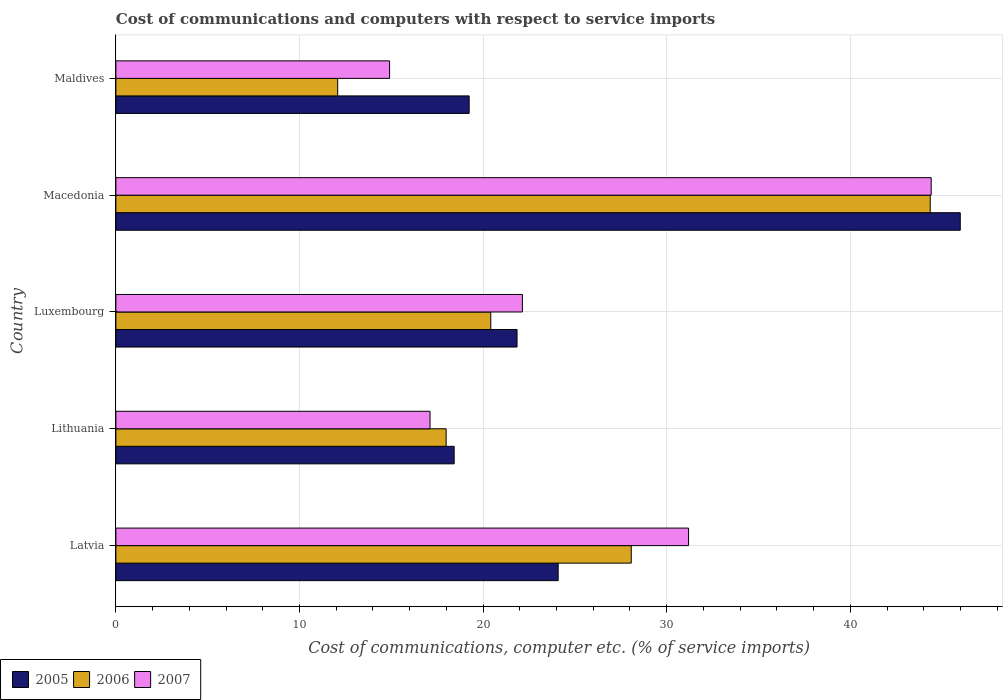How many bars are there on the 1st tick from the top?
Give a very brief answer. 3. How many bars are there on the 4th tick from the bottom?
Make the answer very short. 3. What is the label of the 5th group of bars from the top?
Keep it short and to the point. Latvia. In how many cases, is the number of bars for a given country not equal to the number of legend labels?
Give a very brief answer. 0. What is the cost of communications and computers in 2007 in Maldives?
Keep it short and to the point. 14.91. Across all countries, what is the maximum cost of communications and computers in 2005?
Keep it short and to the point. 45.99. Across all countries, what is the minimum cost of communications and computers in 2007?
Your answer should be very brief. 14.91. In which country was the cost of communications and computers in 2006 maximum?
Keep it short and to the point. Macedonia. In which country was the cost of communications and computers in 2007 minimum?
Ensure brevity in your answer.  Maldives. What is the total cost of communications and computers in 2007 in the graph?
Your answer should be compact. 129.76. What is the difference between the cost of communications and computers in 2006 in Luxembourg and that in Maldives?
Ensure brevity in your answer.  8.34. What is the difference between the cost of communications and computers in 2005 in Maldives and the cost of communications and computers in 2007 in Latvia?
Give a very brief answer. -11.95. What is the average cost of communications and computers in 2007 per country?
Your response must be concise. 25.95. What is the difference between the cost of communications and computers in 2007 and cost of communications and computers in 2005 in Maldives?
Offer a terse response. -4.33. What is the ratio of the cost of communications and computers in 2005 in Luxembourg to that in Macedonia?
Provide a short and direct response. 0.48. What is the difference between the highest and the second highest cost of communications and computers in 2006?
Provide a short and direct response. 16.28. What is the difference between the highest and the lowest cost of communications and computers in 2007?
Your answer should be compact. 29.5. In how many countries, is the cost of communications and computers in 2006 greater than the average cost of communications and computers in 2006 taken over all countries?
Provide a short and direct response. 2. What does the 1st bar from the top in Latvia represents?
Give a very brief answer. 2007. Is it the case that in every country, the sum of the cost of communications and computers in 2007 and cost of communications and computers in 2005 is greater than the cost of communications and computers in 2006?
Your response must be concise. Yes. How many bars are there?
Provide a short and direct response. 15. Are all the bars in the graph horizontal?
Your response must be concise. Yes. Are the values on the major ticks of X-axis written in scientific E-notation?
Your answer should be very brief. No. Does the graph contain any zero values?
Your answer should be compact. No. Does the graph contain grids?
Your answer should be very brief. Yes. What is the title of the graph?
Offer a terse response. Cost of communications and computers with respect to service imports. What is the label or title of the X-axis?
Ensure brevity in your answer.  Cost of communications, computer etc. (% of service imports). What is the Cost of communications, computer etc. (% of service imports) in 2005 in Latvia?
Your response must be concise. 24.09. What is the Cost of communications, computer etc. (% of service imports) in 2006 in Latvia?
Your answer should be very brief. 28.07. What is the Cost of communications, computer etc. (% of service imports) in 2007 in Latvia?
Your answer should be very brief. 31.19. What is the Cost of communications, computer etc. (% of service imports) of 2005 in Lithuania?
Keep it short and to the point. 18.43. What is the Cost of communications, computer etc. (% of service imports) in 2006 in Lithuania?
Make the answer very short. 17.99. What is the Cost of communications, computer etc. (% of service imports) of 2007 in Lithuania?
Provide a succinct answer. 17.11. What is the Cost of communications, computer etc. (% of service imports) of 2005 in Luxembourg?
Give a very brief answer. 21.85. What is the Cost of communications, computer etc. (% of service imports) of 2006 in Luxembourg?
Your answer should be compact. 20.42. What is the Cost of communications, computer etc. (% of service imports) in 2007 in Luxembourg?
Your answer should be compact. 22.14. What is the Cost of communications, computer etc. (% of service imports) of 2005 in Macedonia?
Offer a very short reply. 45.99. What is the Cost of communications, computer etc. (% of service imports) of 2006 in Macedonia?
Ensure brevity in your answer.  44.35. What is the Cost of communications, computer etc. (% of service imports) of 2007 in Macedonia?
Your answer should be compact. 44.41. What is the Cost of communications, computer etc. (% of service imports) in 2005 in Maldives?
Ensure brevity in your answer.  19.24. What is the Cost of communications, computer etc. (% of service imports) in 2006 in Maldives?
Make the answer very short. 12.08. What is the Cost of communications, computer etc. (% of service imports) of 2007 in Maldives?
Your answer should be compact. 14.91. Across all countries, what is the maximum Cost of communications, computer etc. (% of service imports) in 2005?
Give a very brief answer. 45.99. Across all countries, what is the maximum Cost of communications, computer etc. (% of service imports) of 2006?
Your answer should be very brief. 44.35. Across all countries, what is the maximum Cost of communications, computer etc. (% of service imports) of 2007?
Your answer should be very brief. 44.41. Across all countries, what is the minimum Cost of communications, computer etc. (% of service imports) of 2005?
Ensure brevity in your answer.  18.43. Across all countries, what is the minimum Cost of communications, computer etc. (% of service imports) of 2006?
Offer a terse response. 12.08. Across all countries, what is the minimum Cost of communications, computer etc. (% of service imports) in 2007?
Make the answer very short. 14.91. What is the total Cost of communications, computer etc. (% of service imports) in 2005 in the graph?
Provide a succinct answer. 129.6. What is the total Cost of communications, computer etc. (% of service imports) of 2006 in the graph?
Your answer should be compact. 122.91. What is the total Cost of communications, computer etc. (% of service imports) in 2007 in the graph?
Offer a terse response. 129.76. What is the difference between the Cost of communications, computer etc. (% of service imports) of 2005 in Latvia and that in Lithuania?
Offer a very short reply. 5.66. What is the difference between the Cost of communications, computer etc. (% of service imports) of 2006 in Latvia and that in Lithuania?
Keep it short and to the point. 10.08. What is the difference between the Cost of communications, computer etc. (% of service imports) in 2007 in Latvia and that in Lithuania?
Your answer should be very brief. 14.08. What is the difference between the Cost of communications, computer etc. (% of service imports) of 2005 in Latvia and that in Luxembourg?
Your response must be concise. 2.24. What is the difference between the Cost of communications, computer etc. (% of service imports) of 2006 in Latvia and that in Luxembourg?
Ensure brevity in your answer.  7.65. What is the difference between the Cost of communications, computer etc. (% of service imports) of 2007 in Latvia and that in Luxembourg?
Your answer should be very brief. 9.05. What is the difference between the Cost of communications, computer etc. (% of service imports) in 2005 in Latvia and that in Macedonia?
Offer a very short reply. -21.9. What is the difference between the Cost of communications, computer etc. (% of service imports) of 2006 in Latvia and that in Macedonia?
Offer a very short reply. -16.28. What is the difference between the Cost of communications, computer etc. (% of service imports) of 2007 in Latvia and that in Macedonia?
Keep it short and to the point. -13.22. What is the difference between the Cost of communications, computer etc. (% of service imports) of 2005 in Latvia and that in Maldives?
Give a very brief answer. 4.85. What is the difference between the Cost of communications, computer etc. (% of service imports) in 2006 in Latvia and that in Maldives?
Make the answer very short. 15.99. What is the difference between the Cost of communications, computer etc. (% of service imports) of 2007 in Latvia and that in Maldives?
Offer a very short reply. 16.28. What is the difference between the Cost of communications, computer etc. (% of service imports) in 2005 in Lithuania and that in Luxembourg?
Make the answer very short. -3.42. What is the difference between the Cost of communications, computer etc. (% of service imports) in 2006 in Lithuania and that in Luxembourg?
Your answer should be compact. -2.43. What is the difference between the Cost of communications, computer etc. (% of service imports) in 2007 in Lithuania and that in Luxembourg?
Give a very brief answer. -5.03. What is the difference between the Cost of communications, computer etc. (% of service imports) of 2005 in Lithuania and that in Macedonia?
Provide a succinct answer. -27.57. What is the difference between the Cost of communications, computer etc. (% of service imports) of 2006 in Lithuania and that in Macedonia?
Your response must be concise. -26.37. What is the difference between the Cost of communications, computer etc. (% of service imports) of 2007 in Lithuania and that in Macedonia?
Give a very brief answer. -27.3. What is the difference between the Cost of communications, computer etc. (% of service imports) in 2005 in Lithuania and that in Maldives?
Provide a short and direct response. -0.82. What is the difference between the Cost of communications, computer etc. (% of service imports) in 2006 in Lithuania and that in Maldives?
Give a very brief answer. 5.91. What is the difference between the Cost of communications, computer etc. (% of service imports) in 2007 in Lithuania and that in Maldives?
Provide a short and direct response. 2.2. What is the difference between the Cost of communications, computer etc. (% of service imports) of 2005 in Luxembourg and that in Macedonia?
Give a very brief answer. -24.14. What is the difference between the Cost of communications, computer etc. (% of service imports) of 2006 in Luxembourg and that in Macedonia?
Your answer should be very brief. -23.93. What is the difference between the Cost of communications, computer etc. (% of service imports) of 2007 in Luxembourg and that in Macedonia?
Provide a short and direct response. -22.27. What is the difference between the Cost of communications, computer etc. (% of service imports) in 2005 in Luxembourg and that in Maldives?
Provide a succinct answer. 2.61. What is the difference between the Cost of communications, computer etc. (% of service imports) of 2006 in Luxembourg and that in Maldives?
Offer a very short reply. 8.34. What is the difference between the Cost of communications, computer etc. (% of service imports) in 2007 in Luxembourg and that in Maldives?
Offer a very short reply. 7.23. What is the difference between the Cost of communications, computer etc. (% of service imports) in 2005 in Macedonia and that in Maldives?
Give a very brief answer. 26.75. What is the difference between the Cost of communications, computer etc. (% of service imports) in 2006 in Macedonia and that in Maldives?
Your response must be concise. 32.27. What is the difference between the Cost of communications, computer etc. (% of service imports) in 2007 in Macedonia and that in Maldives?
Your response must be concise. 29.5. What is the difference between the Cost of communications, computer etc. (% of service imports) of 2005 in Latvia and the Cost of communications, computer etc. (% of service imports) of 2006 in Lithuania?
Provide a succinct answer. 6.1. What is the difference between the Cost of communications, computer etc. (% of service imports) in 2005 in Latvia and the Cost of communications, computer etc. (% of service imports) in 2007 in Lithuania?
Provide a short and direct response. 6.98. What is the difference between the Cost of communications, computer etc. (% of service imports) of 2006 in Latvia and the Cost of communications, computer etc. (% of service imports) of 2007 in Lithuania?
Give a very brief answer. 10.96. What is the difference between the Cost of communications, computer etc. (% of service imports) of 2005 in Latvia and the Cost of communications, computer etc. (% of service imports) of 2006 in Luxembourg?
Your response must be concise. 3.67. What is the difference between the Cost of communications, computer etc. (% of service imports) of 2005 in Latvia and the Cost of communications, computer etc. (% of service imports) of 2007 in Luxembourg?
Your response must be concise. 1.95. What is the difference between the Cost of communications, computer etc. (% of service imports) of 2006 in Latvia and the Cost of communications, computer etc. (% of service imports) of 2007 in Luxembourg?
Make the answer very short. 5.93. What is the difference between the Cost of communications, computer etc. (% of service imports) in 2005 in Latvia and the Cost of communications, computer etc. (% of service imports) in 2006 in Macedonia?
Keep it short and to the point. -20.26. What is the difference between the Cost of communications, computer etc. (% of service imports) of 2005 in Latvia and the Cost of communications, computer etc. (% of service imports) of 2007 in Macedonia?
Offer a terse response. -20.32. What is the difference between the Cost of communications, computer etc. (% of service imports) in 2006 in Latvia and the Cost of communications, computer etc. (% of service imports) in 2007 in Macedonia?
Make the answer very short. -16.34. What is the difference between the Cost of communications, computer etc. (% of service imports) of 2005 in Latvia and the Cost of communications, computer etc. (% of service imports) of 2006 in Maldives?
Ensure brevity in your answer.  12.01. What is the difference between the Cost of communications, computer etc. (% of service imports) in 2005 in Latvia and the Cost of communications, computer etc. (% of service imports) in 2007 in Maldives?
Keep it short and to the point. 9.18. What is the difference between the Cost of communications, computer etc. (% of service imports) of 2006 in Latvia and the Cost of communications, computer etc. (% of service imports) of 2007 in Maldives?
Give a very brief answer. 13.16. What is the difference between the Cost of communications, computer etc. (% of service imports) of 2005 in Lithuania and the Cost of communications, computer etc. (% of service imports) of 2006 in Luxembourg?
Provide a short and direct response. -1.99. What is the difference between the Cost of communications, computer etc. (% of service imports) of 2005 in Lithuania and the Cost of communications, computer etc. (% of service imports) of 2007 in Luxembourg?
Provide a succinct answer. -3.72. What is the difference between the Cost of communications, computer etc. (% of service imports) of 2006 in Lithuania and the Cost of communications, computer etc. (% of service imports) of 2007 in Luxembourg?
Your response must be concise. -4.15. What is the difference between the Cost of communications, computer etc. (% of service imports) of 2005 in Lithuania and the Cost of communications, computer etc. (% of service imports) of 2006 in Macedonia?
Give a very brief answer. -25.93. What is the difference between the Cost of communications, computer etc. (% of service imports) of 2005 in Lithuania and the Cost of communications, computer etc. (% of service imports) of 2007 in Macedonia?
Ensure brevity in your answer.  -25.98. What is the difference between the Cost of communications, computer etc. (% of service imports) in 2006 in Lithuania and the Cost of communications, computer etc. (% of service imports) in 2007 in Macedonia?
Offer a terse response. -26.42. What is the difference between the Cost of communications, computer etc. (% of service imports) of 2005 in Lithuania and the Cost of communications, computer etc. (% of service imports) of 2006 in Maldives?
Make the answer very short. 6.34. What is the difference between the Cost of communications, computer etc. (% of service imports) of 2005 in Lithuania and the Cost of communications, computer etc. (% of service imports) of 2007 in Maldives?
Offer a terse response. 3.52. What is the difference between the Cost of communications, computer etc. (% of service imports) in 2006 in Lithuania and the Cost of communications, computer etc. (% of service imports) in 2007 in Maldives?
Provide a succinct answer. 3.08. What is the difference between the Cost of communications, computer etc. (% of service imports) in 2005 in Luxembourg and the Cost of communications, computer etc. (% of service imports) in 2006 in Macedonia?
Offer a very short reply. -22.5. What is the difference between the Cost of communications, computer etc. (% of service imports) of 2005 in Luxembourg and the Cost of communications, computer etc. (% of service imports) of 2007 in Macedonia?
Offer a very short reply. -22.56. What is the difference between the Cost of communications, computer etc. (% of service imports) of 2006 in Luxembourg and the Cost of communications, computer etc. (% of service imports) of 2007 in Macedonia?
Give a very brief answer. -23.99. What is the difference between the Cost of communications, computer etc. (% of service imports) in 2005 in Luxembourg and the Cost of communications, computer etc. (% of service imports) in 2006 in Maldives?
Ensure brevity in your answer.  9.77. What is the difference between the Cost of communications, computer etc. (% of service imports) in 2005 in Luxembourg and the Cost of communications, computer etc. (% of service imports) in 2007 in Maldives?
Your response must be concise. 6.94. What is the difference between the Cost of communications, computer etc. (% of service imports) of 2006 in Luxembourg and the Cost of communications, computer etc. (% of service imports) of 2007 in Maldives?
Provide a succinct answer. 5.51. What is the difference between the Cost of communications, computer etc. (% of service imports) of 2005 in Macedonia and the Cost of communications, computer etc. (% of service imports) of 2006 in Maldives?
Give a very brief answer. 33.91. What is the difference between the Cost of communications, computer etc. (% of service imports) of 2005 in Macedonia and the Cost of communications, computer etc. (% of service imports) of 2007 in Maldives?
Give a very brief answer. 31.08. What is the difference between the Cost of communications, computer etc. (% of service imports) in 2006 in Macedonia and the Cost of communications, computer etc. (% of service imports) in 2007 in Maldives?
Keep it short and to the point. 29.45. What is the average Cost of communications, computer etc. (% of service imports) in 2005 per country?
Your answer should be very brief. 25.92. What is the average Cost of communications, computer etc. (% of service imports) in 2006 per country?
Offer a terse response. 24.58. What is the average Cost of communications, computer etc. (% of service imports) of 2007 per country?
Your answer should be compact. 25.95. What is the difference between the Cost of communications, computer etc. (% of service imports) in 2005 and Cost of communications, computer etc. (% of service imports) in 2006 in Latvia?
Provide a short and direct response. -3.98. What is the difference between the Cost of communications, computer etc. (% of service imports) of 2005 and Cost of communications, computer etc. (% of service imports) of 2007 in Latvia?
Make the answer very short. -7.1. What is the difference between the Cost of communications, computer etc. (% of service imports) in 2006 and Cost of communications, computer etc. (% of service imports) in 2007 in Latvia?
Keep it short and to the point. -3.12. What is the difference between the Cost of communications, computer etc. (% of service imports) in 2005 and Cost of communications, computer etc. (% of service imports) in 2006 in Lithuania?
Ensure brevity in your answer.  0.44. What is the difference between the Cost of communications, computer etc. (% of service imports) of 2005 and Cost of communications, computer etc. (% of service imports) of 2007 in Lithuania?
Offer a very short reply. 1.31. What is the difference between the Cost of communications, computer etc. (% of service imports) in 2006 and Cost of communications, computer etc. (% of service imports) in 2007 in Lithuania?
Offer a very short reply. 0.88. What is the difference between the Cost of communications, computer etc. (% of service imports) of 2005 and Cost of communications, computer etc. (% of service imports) of 2006 in Luxembourg?
Your response must be concise. 1.43. What is the difference between the Cost of communications, computer etc. (% of service imports) in 2005 and Cost of communications, computer etc. (% of service imports) in 2007 in Luxembourg?
Offer a terse response. -0.29. What is the difference between the Cost of communications, computer etc. (% of service imports) in 2006 and Cost of communications, computer etc. (% of service imports) in 2007 in Luxembourg?
Provide a succinct answer. -1.72. What is the difference between the Cost of communications, computer etc. (% of service imports) of 2005 and Cost of communications, computer etc. (% of service imports) of 2006 in Macedonia?
Provide a succinct answer. 1.64. What is the difference between the Cost of communications, computer etc. (% of service imports) of 2005 and Cost of communications, computer etc. (% of service imports) of 2007 in Macedonia?
Make the answer very short. 1.58. What is the difference between the Cost of communications, computer etc. (% of service imports) in 2006 and Cost of communications, computer etc. (% of service imports) in 2007 in Macedonia?
Offer a terse response. -0.05. What is the difference between the Cost of communications, computer etc. (% of service imports) of 2005 and Cost of communications, computer etc. (% of service imports) of 2006 in Maldives?
Provide a succinct answer. 7.16. What is the difference between the Cost of communications, computer etc. (% of service imports) in 2005 and Cost of communications, computer etc. (% of service imports) in 2007 in Maldives?
Offer a very short reply. 4.33. What is the difference between the Cost of communications, computer etc. (% of service imports) of 2006 and Cost of communications, computer etc. (% of service imports) of 2007 in Maldives?
Your answer should be compact. -2.83. What is the ratio of the Cost of communications, computer etc. (% of service imports) of 2005 in Latvia to that in Lithuania?
Your answer should be compact. 1.31. What is the ratio of the Cost of communications, computer etc. (% of service imports) in 2006 in Latvia to that in Lithuania?
Offer a very short reply. 1.56. What is the ratio of the Cost of communications, computer etc. (% of service imports) in 2007 in Latvia to that in Lithuania?
Make the answer very short. 1.82. What is the ratio of the Cost of communications, computer etc. (% of service imports) of 2005 in Latvia to that in Luxembourg?
Give a very brief answer. 1.1. What is the ratio of the Cost of communications, computer etc. (% of service imports) of 2006 in Latvia to that in Luxembourg?
Give a very brief answer. 1.37. What is the ratio of the Cost of communications, computer etc. (% of service imports) of 2007 in Latvia to that in Luxembourg?
Ensure brevity in your answer.  1.41. What is the ratio of the Cost of communications, computer etc. (% of service imports) of 2005 in Latvia to that in Macedonia?
Ensure brevity in your answer.  0.52. What is the ratio of the Cost of communications, computer etc. (% of service imports) of 2006 in Latvia to that in Macedonia?
Provide a short and direct response. 0.63. What is the ratio of the Cost of communications, computer etc. (% of service imports) in 2007 in Latvia to that in Macedonia?
Give a very brief answer. 0.7. What is the ratio of the Cost of communications, computer etc. (% of service imports) in 2005 in Latvia to that in Maldives?
Make the answer very short. 1.25. What is the ratio of the Cost of communications, computer etc. (% of service imports) of 2006 in Latvia to that in Maldives?
Offer a terse response. 2.32. What is the ratio of the Cost of communications, computer etc. (% of service imports) in 2007 in Latvia to that in Maldives?
Provide a short and direct response. 2.09. What is the ratio of the Cost of communications, computer etc. (% of service imports) in 2005 in Lithuania to that in Luxembourg?
Your answer should be very brief. 0.84. What is the ratio of the Cost of communications, computer etc. (% of service imports) in 2006 in Lithuania to that in Luxembourg?
Your answer should be very brief. 0.88. What is the ratio of the Cost of communications, computer etc. (% of service imports) of 2007 in Lithuania to that in Luxembourg?
Offer a terse response. 0.77. What is the ratio of the Cost of communications, computer etc. (% of service imports) in 2005 in Lithuania to that in Macedonia?
Offer a terse response. 0.4. What is the ratio of the Cost of communications, computer etc. (% of service imports) of 2006 in Lithuania to that in Macedonia?
Offer a very short reply. 0.41. What is the ratio of the Cost of communications, computer etc. (% of service imports) of 2007 in Lithuania to that in Macedonia?
Your response must be concise. 0.39. What is the ratio of the Cost of communications, computer etc. (% of service imports) of 2005 in Lithuania to that in Maldives?
Your answer should be very brief. 0.96. What is the ratio of the Cost of communications, computer etc. (% of service imports) of 2006 in Lithuania to that in Maldives?
Provide a succinct answer. 1.49. What is the ratio of the Cost of communications, computer etc. (% of service imports) in 2007 in Lithuania to that in Maldives?
Provide a short and direct response. 1.15. What is the ratio of the Cost of communications, computer etc. (% of service imports) of 2005 in Luxembourg to that in Macedonia?
Provide a succinct answer. 0.48. What is the ratio of the Cost of communications, computer etc. (% of service imports) in 2006 in Luxembourg to that in Macedonia?
Your response must be concise. 0.46. What is the ratio of the Cost of communications, computer etc. (% of service imports) in 2007 in Luxembourg to that in Macedonia?
Keep it short and to the point. 0.5. What is the ratio of the Cost of communications, computer etc. (% of service imports) of 2005 in Luxembourg to that in Maldives?
Your response must be concise. 1.14. What is the ratio of the Cost of communications, computer etc. (% of service imports) in 2006 in Luxembourg to that in Maldives?
Provide a short and direct response. 1.69. What is the ratio of the Cost of communications, computer etc. (% of service imports) in 2007 in Luxembourg to that in Maldives?
Provide a short and direct response. 1.49. What is the ratio of the Cost of communications, computer etc. (% of service imports) of 2005 in Macedonia to that in Maldives?
Offer a terse response. 2.39. What is the ratio of the Cost of communications, computer etc. (% of service imports) in 2006 in Macedonia to that in Maldives?
Offer a very short reply. 3.67. What is the ratio of the Cost of communications, computer etc. (% of service imports) of 2007 in Macedonia to that in Maldives?
Your answer should be compact. 2.98. What is the difference between the highest and the second highest Cost of communications, computer etc. (% of service imports) of 2005?
Your response must be concise. 21.9. What is the difference between the highest and the second highest Cost of communications, computer etc. (% of service imports) of 2006?
Provide a short and direct response. 16.28. What is the difference between the highest and the second highest Cost of communications, computer etc. (% of service imports) of 2007?
Provide a short and direct response. 13.22. What is the difference between the highest and the lowest Cost of communications, computer etc. (% of service imports) in 2005?
Your response must be concise. 27.57. What is the difference between the highest and the lowest Cost of communications, computer etc. (% of service imports) in 2006?
Offer a very short reply. 32.27. What is the difference between the highest and the lowest Cost of communications, computer etc. (% of service imports) of 2007?
Keep it short and to the point. 29.5. 